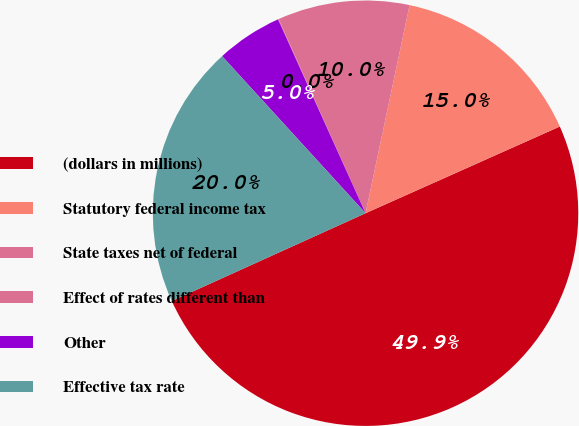<chart> <loc_0><loc_0><loc_500><loc_500><pie_chart><fcel>(dollars in millions)<fcel>Statutory federal income tax<fcel>State taxes net of federal<fcel>Effect of rates different than<fcel>Other<fcel>Effective tax rate<nl><fcel>49.91%<fcel>15.0%<fcel>10.02%<fcel>0.05%<fcel>5.03%<fcel>19.99%<nl></chart> 